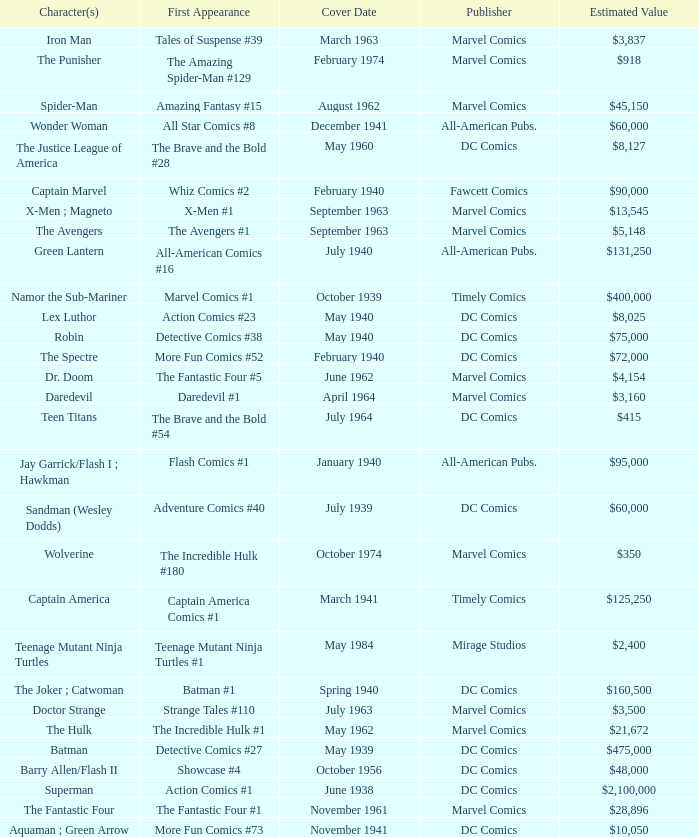Which character first appeared in Amazing Fantasy #15? Spider-Man. 